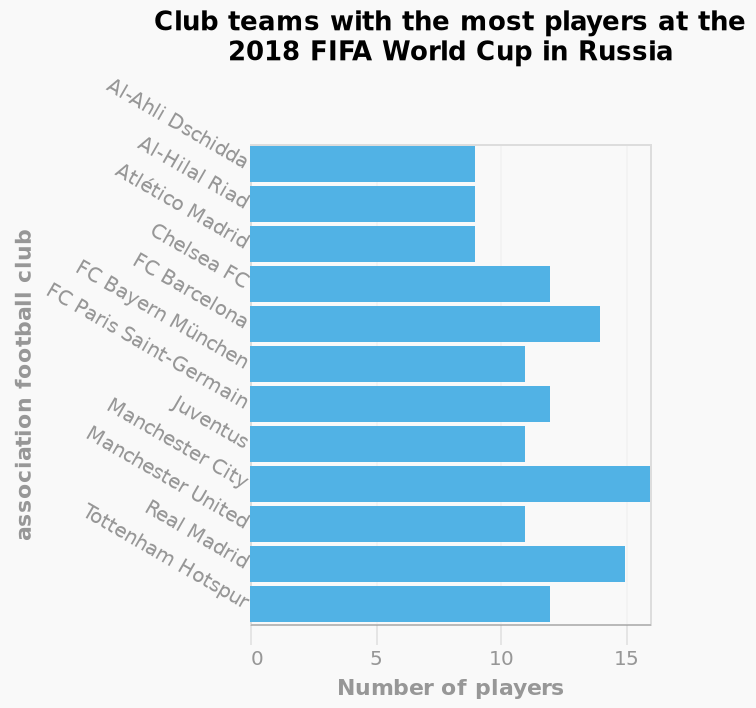<image>
Offer a thorough analysis of the image. Manchester city had the most players at the 2018 Fifa cup. No teams had less than 9 players. Which club team had the least players at the 2018 FIFA World Cup? The club team with the least players at the 2018 FIFA World Cup is Al-Ahli Dschidda. Were there any teams with more players than Manchester City at the 2018 Fifa cup? The description does not provide information on whether any teams had more players than Manchester City at the 2018 Fifa cup. How many players did Manchester City have at the 2018 Fifa cup? The exact number of players Manchester City had at the 2018 Fifa cup is not provided in the description. Did Manchester City have the least players at the 2018 Fifa cup? No.Manchester city had the most players at the 2018 Fifa cup. No teams had less than 9 players. 